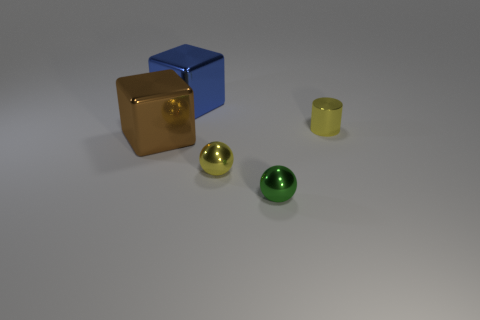What number of other objects are the same color as the cylinder?
Provide a succinct answer. 1. There is a brown metallic block; are there any large brown shiny blocks behind it?
Ensure brevity in your answer.  No. How many things are small metal spheres or small yellow objects behind the large brown metal cube?
Provide a short and direct response. 3. Are there any tiny green objects that are behind the object that is to the right of the green metal object?
Provide a short and direct response. No. What shape is the tiny yellow thing in front of the tiny yellow object that is right of the yellow object in front of the small cylinder?
Make the answer very short. Sphere. The object that is behind the brown thing and on the right side of the large blue metal block is what color?
Provide a succinct answer. Yellow. What is the shape of the big thing that is behind the big brown metallic object?
Provide a succinct answer. Cube. What is the shape of the large thing that is made of the same material as the large blue cube?
Offer a very short reply. Cube. How many rubber objects are big green things or tiny yellow cylinders?
Provide a succinct answer. 0. There is a small sphere that is in front of the tiny sphere that is left of the green thing; how many yellow metal things are on the right side of it?
Offer a very short reply. 1. 